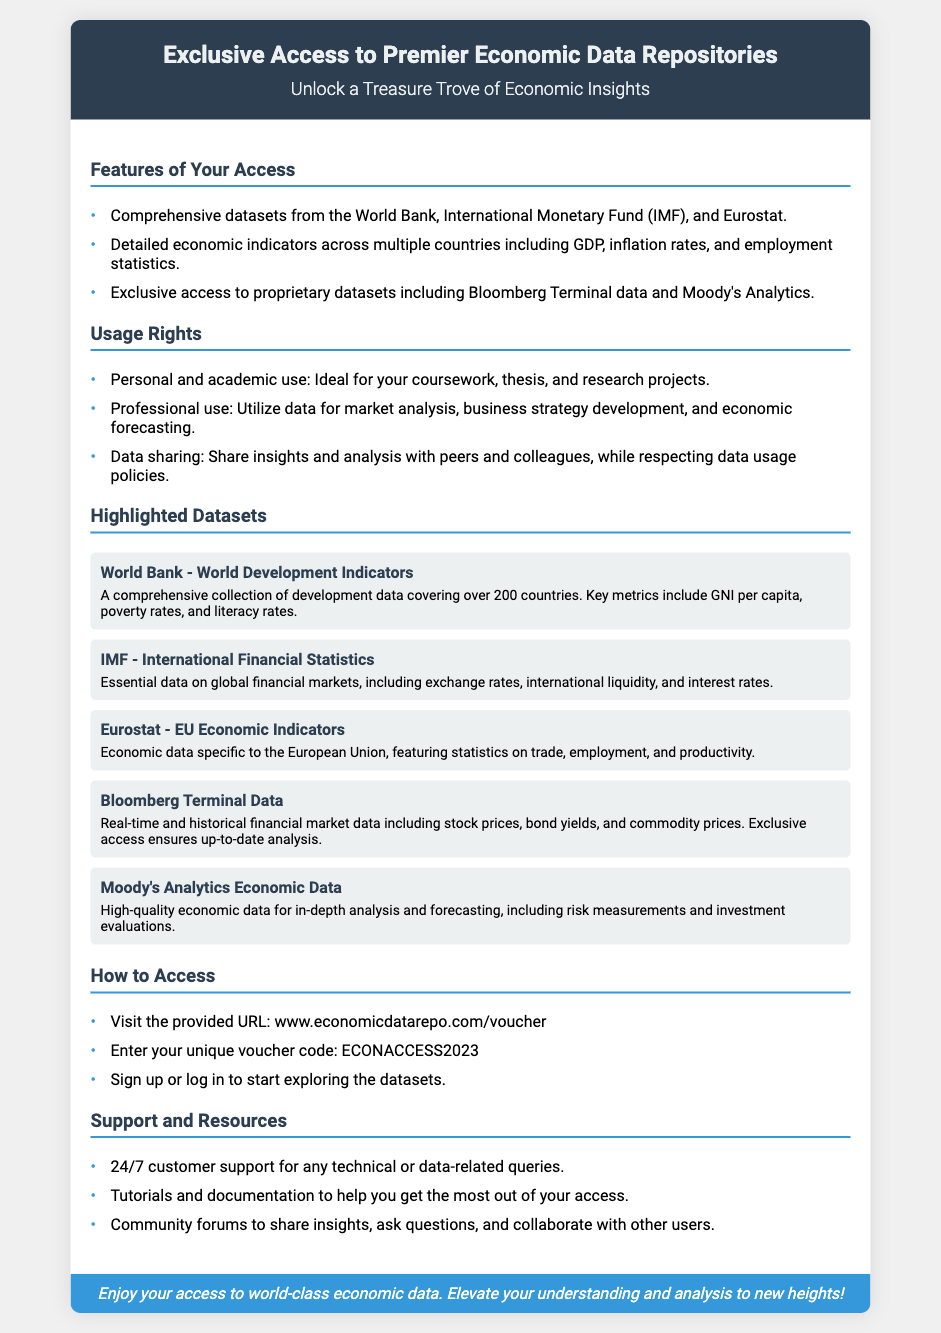What is the title of the voucher? The title of the voucher is mentioned in the header section of the document.
Answer: Exclusive Access to Premier Economic Data Repositories How many highlighted datasets are mentioned? The number of highlighted datasets is indicated in the section titled "Highlighted Datasets."
Answer: Five What type of access is ideal for coursework and research projects? This information is found in the "Usage Rights" section of the document.
Answer: Personal and academic use Which organization provides the dataset on global financial markets? The organization related to the specific dataset is listed under the highlighted datasets.
Answer: IMF What is the unique voucher code provided for access? The voucher code for access is specified in the "How to Access" section.
Answer: ECONACCESS2023 What type of support is available 24/7? The type of support available is mentioned in the "Support and Resources" section.
Answer: Customer support What are the primary types of datasets included in the access? This information can be retrieved from the "Features of Your Access" section.
Answer: Comprehensive datasets and proprietary datasets Which dataset includes information on the European Union? The dataset related to the European Union is identified in the "Highlighted Datasets."
Answer: Eurostat - EU Economic Indicators How can users start exploring the datasets? The method for starting exploration is detailed in the "How to Access" section.
Answer: Visit the provided URL 